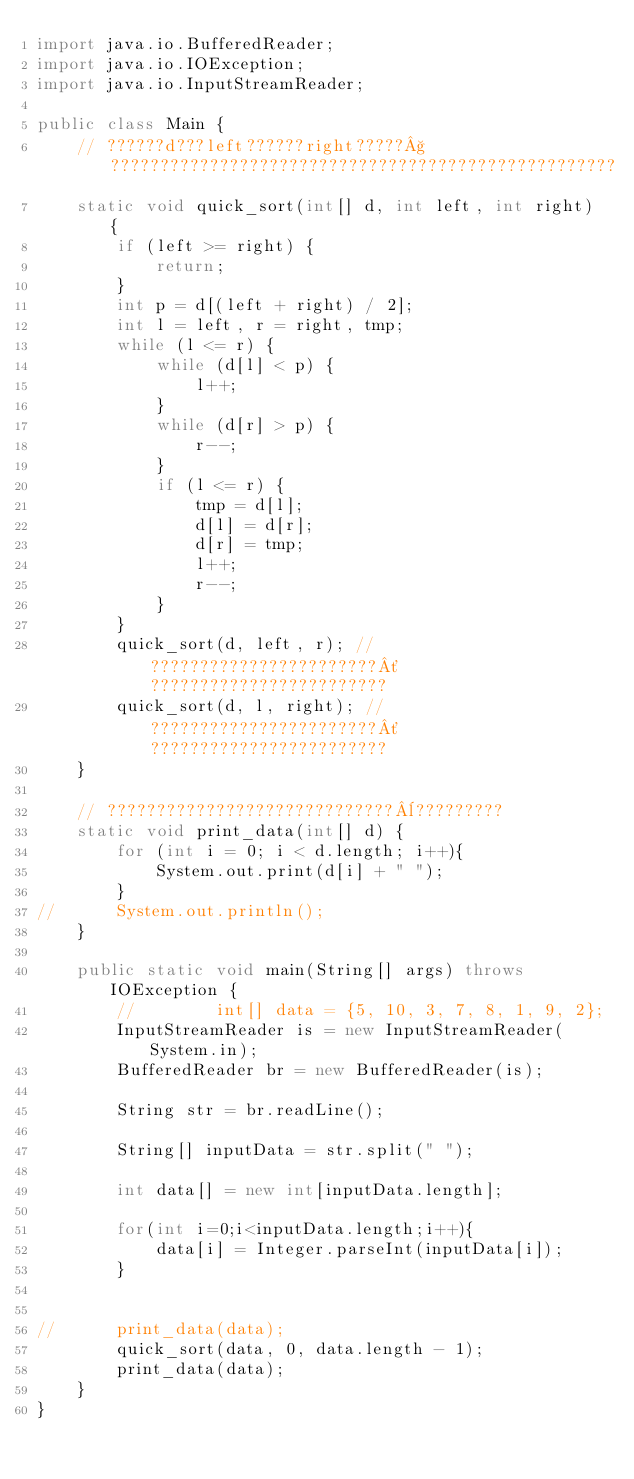Convert code to text. <code><loc_0><loc_0><loc_500><loc_500><_Java_>import java.io.BufferedReader;
import java.io.IOException;
import java.io.InputStreamReader;

public class Main {
	// ??????d???left??????right?????§???????????????????????????????????????????????????
	static void quick_sort(int[] d, int left, int right) {
		if (left >= right) {
			return;
		}
		int p = d[(left + right) / 2];
		int l = left, r = right, tmp;
		while (l <= r) {
			while (d[l] < p) {
				l++;
			}
			while (d[r] > p) {
				r--;
			}
			if (l <= r) {
				tmp = d[l];
				d[l] = d[r];
				d[r] = tmp;
				l++;
				r--;
			}
		}
		quick_sort(d, left, r); // ???????????????????????´????????????????????????
		quick_sort(d, l, right); // ???????????????????????´????????????????????????
	}

	// ?????????????????????????????¨?????????
	static void print_data(int[] d) {
		for (int i = 0; i < d.length; i++){
			System.out.print(d[i] + " ");
		}
//		System.out.println();
	}

	public static void main(String[] args) throws IOException {
		//        int[] data = {5, 10, 3, 7, 8, 1, 9, 2};
		InputStreamReader is = new InputStreamReader(System.in);
		BufferedReader br = new BufferedReader(is);

		String str = br.readLine();

		String[] inputData = str.split(" ");

		int data[] = new int[inputData.length];

		for(int i=0;i<inputData.length;i++){
			data[i] = Integer.parseInt(inputData[i]);
		}


//		print_data(data);
		quick_sort(data, 0, data.length - 1);
		print_data(data);
	}
}</code> 